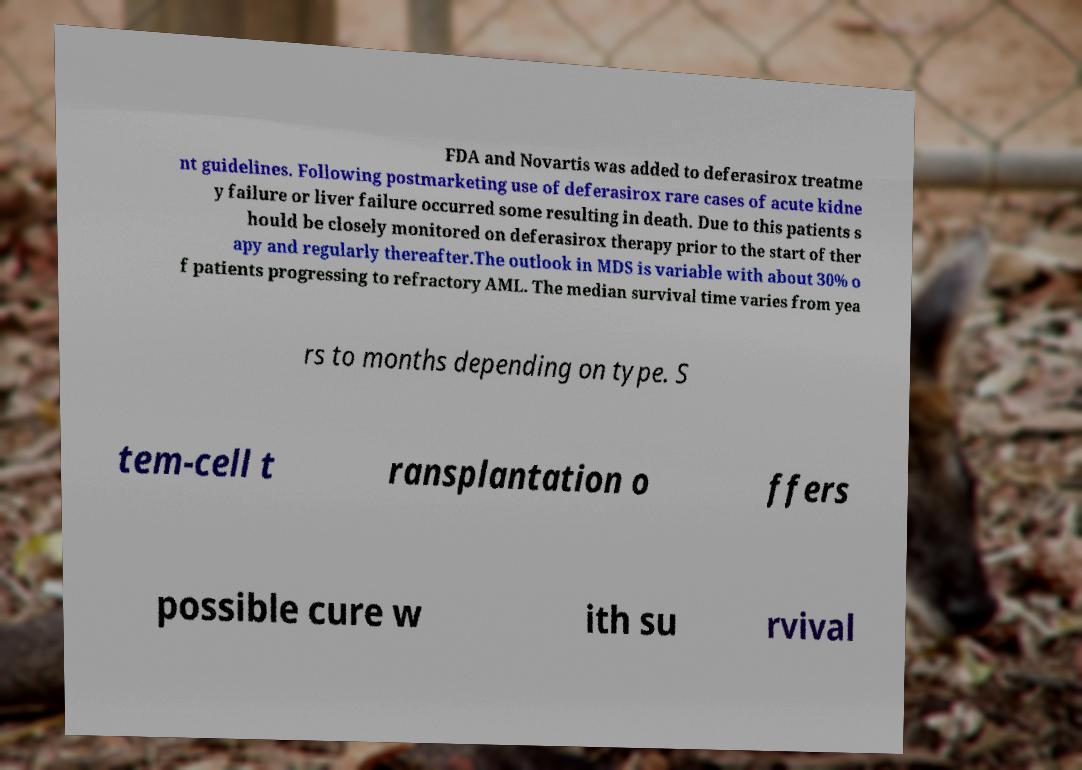Please read and relay the text visible in this image. What does it say? FDA and Novartis was added to deferasirox treatme nt guidelines. Following postmarketing use of deferasirox rare cases of acute kidne y failure or liver failure occurred some resulting in death. Due to this patients s hould be closely monitored on deferasirox therapy prior to the start of ther apy and regularly thereafter.The outlook in MDS is variable with about 30% o f patients progressing to refractory AML. The median survival time varies from yea rs to months depending on type. S tem-cell t ransplantation o ffers possible cure w ith su rvival 